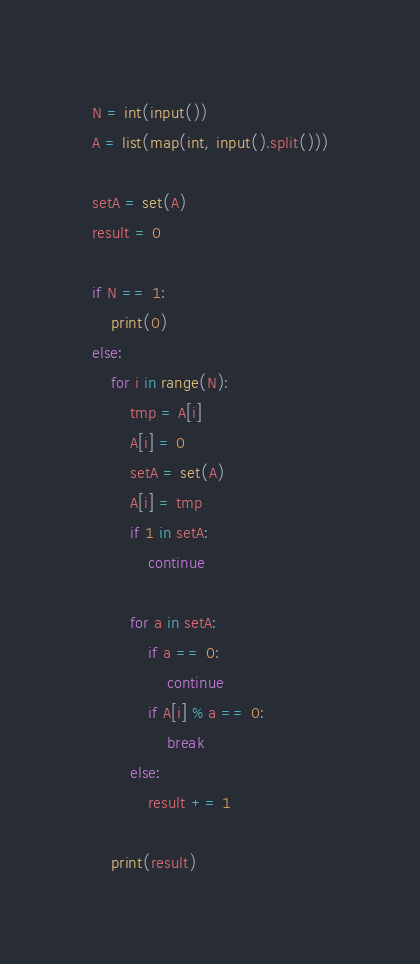Convert code to text. <code><loc_0><loc_0><loc_500><loc_500><_Python_>N = int(input())
A = list(map(int, input().split()))

setA = set(A)
result = 0

if N == 1:
    print(0)
else:
    for i in range(N):
        tmp = A[i]
        A[i] = 0
        setA = set(A)
        A[i] = tmp
        if 1 in setA:
            continue

        for a in setA:
            if a == 0:
                continue
            if A[i] % a == 0:
                break
        else:
            result += 1

    print(result)
</code> 